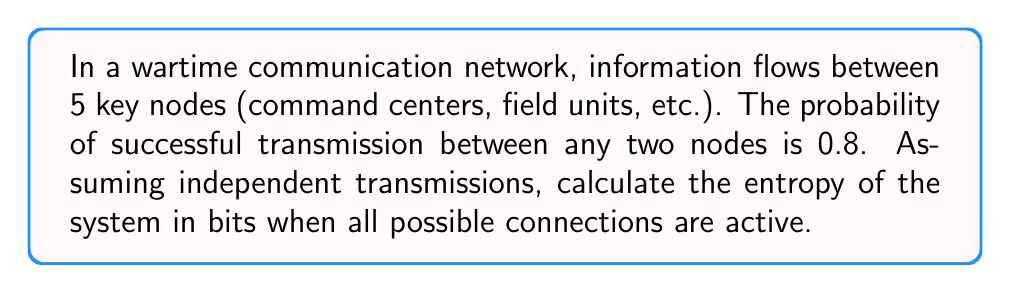Teach me how to tackle this problem. Let's approach this step-by-step:

1) First, we need to determine the number of possible connections in the network. With 5 nodes, the number of connections is:

   $$\binom{5}{2} = \frac{5!}{2!(5-2)!} = 10$$

2) Each connection has two possible states: successful (p = 0.8) or unsuccessful (q = 1 - p = 0.2).

3) The entropy of a single connection is given by:

   $$H = -p \log_2 p - q \log_2 q$$

4) Substituting the values:

   $$H = -0.8 \log_2 0.8 - 0.2 \log_2 0.2$$

5) Calculate:

   $$H = -0.8 (-0.3219) - 0.2 (-2.3219) = 0.2575 + 0.4644 = 0.7219 \text{ bits}$$

6) Since there are 10 independent connections, and entropy is additive for independent events, the total entropy of the system is:

   $$H_{total} = 10 \times 0.7219 = 7.219 \text{ bits}$$

This entropy value represents the average amount of information needed to describe the state of the entire communication network.
Answer: 7.219 bits 